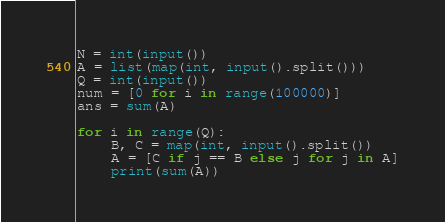Convert code to text. <code><loc_0><loc_0><loc_500><loc_500><_Python_>N = int(input())
A = list(map(int, input().split()))
Q = int(input())
num = [0 for i in range(100000)]
ans = sum(A)

for i in range(Q):
    B, C = map(int, input().split())
    A = [C if j == B else j for j in A]
    print(sum(A))
</code> 